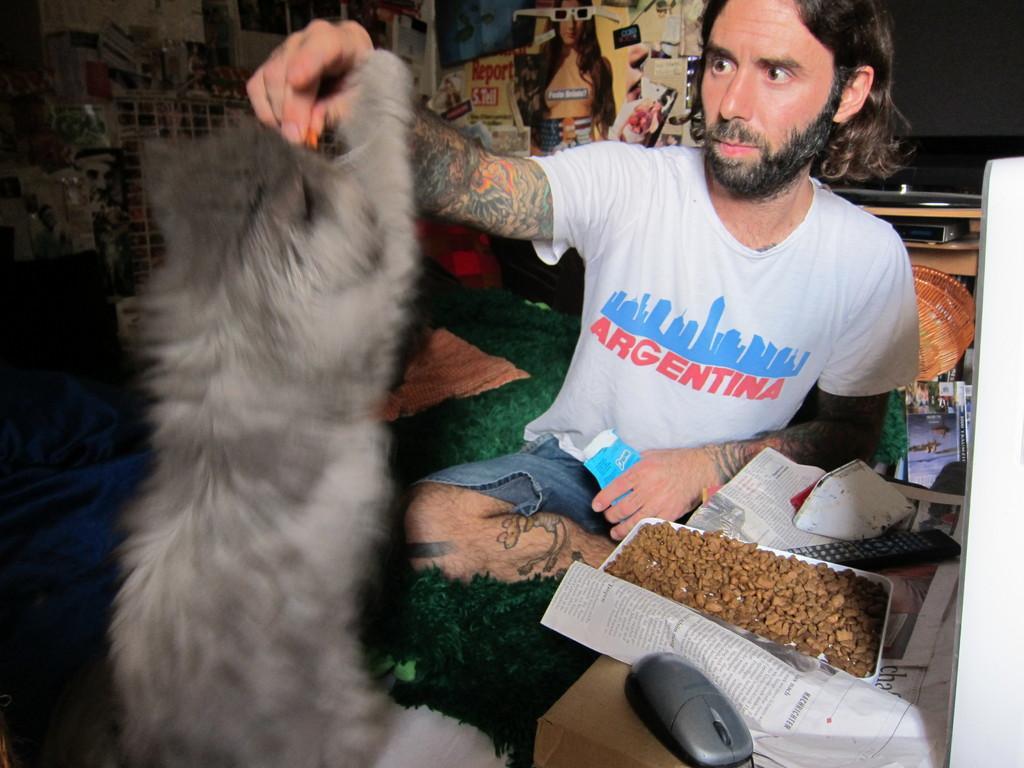In one or two sentences, can you explain what this image depicts? In this image a person sitting on the floor. He is feeding someone food to an animal. Before him there is a box having plate with food and a remote and a mouse are on the box. Few pictures are attached to the wall. 